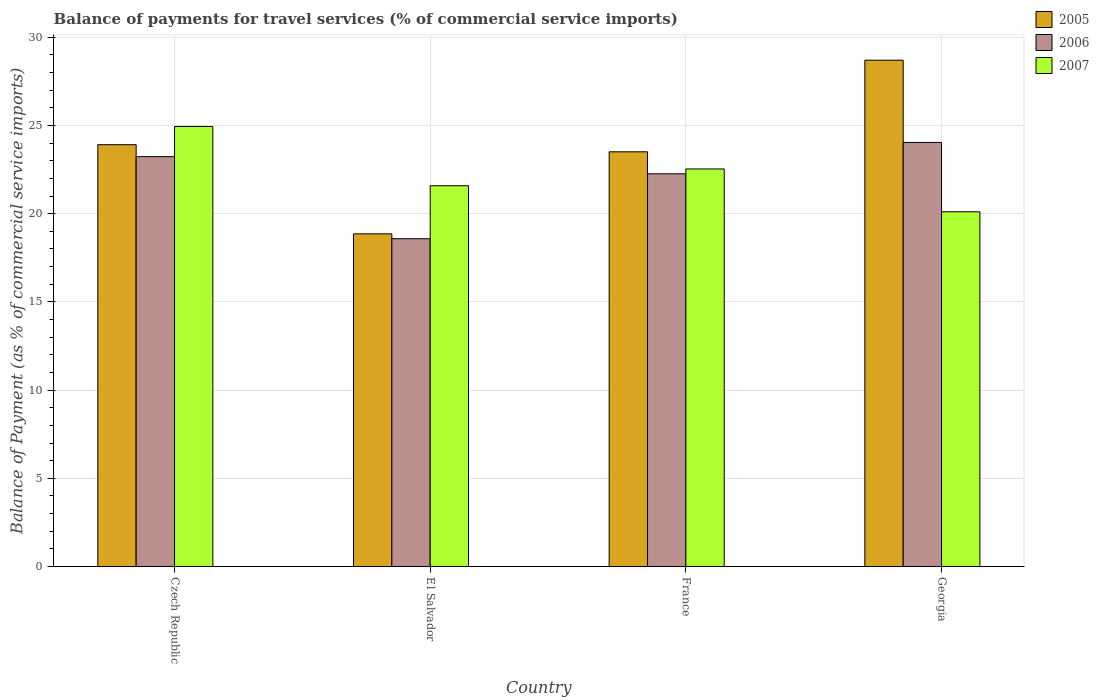Are the number of bars per tick equal to the number of legend labels?
Offer a very short reply. Yes. How many bars are there on the 2nd tick from the left?
Give a very brief answer. 3. How many bars are there on the 3rd tick from the right?
Your response must be concise. 3. What is the label of the 4th group of bars from the left?
Keep it short and to the point. Georgia. What is the balance of payments for travel services in 2006 in Georgia?
Your answer should be very brief. 24.04. Across all countries, what is the maximum balance of payments for travel services in 2007?
Offer a very short reply. 24.94. Across all countries, what is the minimum balance of payments for travel services in 2005?
Provide a succinct answer. 18.86. In which country was the balance of payments for travel services in 2007 maximum?
Keep it short and to the point. Czech Republic. In which country was the balance of payments for travel services in 2005 minimum?
Give a very brief answer. El Salvador. What is the total balance of payments for travel services in 2005 in the graph?
Offer a terse response. 94.98. What is the difference between the balance of payments for travel services in 2006 in France and that in Georgia?
Provide a succinct answer. -1.78. What is the difference between the balance of payments for travel services in 2007 in Czech Republic and the balance of payments for travel services in 2006 in France?
Offer a very short reply. 2.68. What is the average balance of payments for travel services in 2005 per country?
Keep it short and to the point. 23.75. What is the difference between the balance of payments for travel services of/in 2005 and balance of payments for travel services of/in 2007 in Georgia?
Provide a short and direct response. 8.59. In how many countries, is the balance of payments for travel services in 2007 greater than 29 %?
Give a very brief answer. 0. What is the ratio of the balance of payments for travel services in 2006 in Czech Republic to that in El Salvador?
Give a very brief answer. 1.25. Is the difference between the balance of payments for travel services in 2005 in France and Georgia greater than the difference between the balance of payments for travel services in 2007 in France and Georgia?
Your response must be concise. No. What is the difference between the highest and the second highest balance of payments for travel services in 2006?
Give a very brief answer. 1.78. What is the difference between the highest and the lowest balance of payments for travel services in 2006?
Offer a very short reply. 5.46. In how many countries, is the balance of payments for travel services in 2006 greater than the average balance of payments for travel services in 2006 taken over all countries?
Your response must be concise. 3. Is the sum of the balance of payments for travel services in 2007 in El Salvador and France greater than the maximum balance of payments for travel services in 2005 across all countries?
Your response must be concise. Yes. What does the 3rd bar from the left in Georgia represents?
Your answer should be very brief. 2007. What does the 3rd bar from the right in Czech Republic represents?
Your response must be concise. 2005. Is it the case that in every country, the sum of the balance of payments for travel services in 2006 and balance of payments for travel services in 2005 is greater than the balance of payments for travel services in 2007?
Give a very brief answer. Yes. Are all the bars in the graph horizontal?
Your answer should be very brief. No. How many countries are there in the graph?
Provide a succinct answer. 4. What is the difference between two consecutive major ticks on the Y-axis?
Make the answer very short. 5. Does the graph contain grids?
Make the answer very short. Yes. Where does the legend appear in the graph?
Your answer should be compact. Top right. How are the legend labels stacked?
Provide a short and direct response. Vertical. What is the title of the graph?
Keep it short and to the point. Balance of payments for travel services (% of commercial service imports). What is the label or title of the X-axis?
Make the answer very short. Country. What is the label or title of the Y-axis?
Make the answer very short. Balance of Payment (as % of commercial service imports). What is the Balance of Payment (as % of commercial service imports) in 2005 in Czech Republic?
Keep it short and to the point. 23.91. What is the Balance of Payment (as % of commercial service imports) in 2006 in Czech Republic?
Your answer should be very brief. 23.24. What is the Balance of Payment (as % of commercial service imports) in 2007 in Czech Republic?
Give a very brief answer. 24.94. What is the Balance of Payment (as % of commercial service imports) in 2005 in El Salvador?
Provide a short and direct response. 18.86. What is the Balance of Payment (as % of commercial service imports) of 2006 in El Salvador?
Offer a terse response. 18.58. What is the Balance of Payment (as % of commercial service imports) in 2007 in El Salvador?
Your answer should be very brief. 21.59. What is the Balance of Payment (as % of commercial service imports) in 2005 in France?
Make the answer very short. 23.51. What is the Balance of Payment (as % of commercial service imports) of 2006 in France?
Your answer should be compact. 22.26. What is the Balance of Payment (as % of commercial service imports) in 2007 in France?
Provide a succinct answer. 22.54. What is the Balance of Payment (as % of commercial service imports) of 2005 in Georgia?
Provide a short and direct response. 28.7. What is the Balance of Payment (as % of commercial service imports) in 2006 in Georgia?
Keep it short and to the point. 24.04. What is the Balance of Payment (as % of commercial service imports) in 2007 in Georgia?
Your response must be concise. 20.11. Across all countries, what is the maximum Balance of Payment (as % of commercial service imports) in 2005?
Your answer should be very brief. 28.7. Across all countries, what is the maximum Balance of Payment (as % of commercial service imports) of 2006?
Provide a short and direct response. 24.04. Across all countries, what is the maximum Balance of Payment (as % of commercial service imports) of 2007?
Offer a very short reply. 24.94. Across all countries, what is the minimum Balance of Payment (as % of commercial service imports) of 2005?
Your answer should be compact. 18.86. Across all countries, what is the minimum Balance of Payment (as % of commercial service imports) in 2006?
Offer a very short reply. 18.58. Across all countries, what is the minimum Balance of Payment (as % of commercial service imports) of 2007?
Provide a short and direct response. 20.11. What is the total Balance of Payment (as % of commercial service imports) of 2005 in the graph?
Provide a succinct answer. 94.98. What is the total Balance of Payment (as % of commercial service imports) in 2006 in the graph?
Your answer should be compact. 88.12. What is the total Balance of Payment (as % of commercial service imports) in 2007 in the graph?
Your answer should be very brief. 89.17. What is the difference between the Balance of Payment (as % of commercial service imports) in 2005 in Czech Republic and that in El Salvador?
Keep it short and to the point. 5.05. What is the difference between the Balance of Payment (as % of commercial service imports) of 2006 in Czech Republic and that in El Salvador?
Make the answer very short. 4.65. What is the difference between the Balance of Payment (as % of commercial service imports) in 2007 in Czech Republic and that in El Salvador?
Provide a short and direct response. 3.36. What is the difference between the Balance of Payment (as % of commercial service imports) of 2005 in Czech Republic and that in France?
Your response must be concise. 0.4. What is the difference between the Balance of Payment (as % of commercial service imports) in 2006 in Czech Republic and that in France?
Your answer should be compact. 0.97. What is the difference between the Balance of Payment (as % of commercial service imports) in 2007 in Czech Republic and that in France?
Your response must be concise. 2.41. What is the difference between the Balance of Payment (as % of commercial service imports) of 2005 in Czech Republic and that in Georgia?
Offer a very short reply. -4.79. What is the difference between the Balance of Payment (as % of commercial service imports) of 2006 in Czech Republic and that in Georgia?
Provide a succinct answer. -0.8. What is the difference between the Balance of Payment (as % of commercial service imports) of 2007 in Czech Republic and that in Georgia?
Your answer should be very brief. 4.84. What is the difference between the Balance of Payment (as % of commercial service imports) in 2005 in El Salvador and that in France?
Ensure brevity in your answer.  -4.65. What is the difference between the Balance of Payment (as % of commercial service imports) in 2006 in El Salvador and that in France?
Your response must be concise. -3.68. What is the difference between the Balance of Payment (as % of commercial service imports) of 2007 in El Salvador and that in France?
Your response must be concise. -0.95. What is the difference between the Balance of Payment (as % of commercial service imports) of 2005 in El Salvador and that in Georgia?
Your answer should be very brief. -9.85. What is the difference between the Balance of Payment (as % of commercial service imports) in 2006 in El Salvador and that in Georgia?
Give a very brief answer. -5.46. What is the difference between the Balance of Payment (as % of commercial service imports) in 2007 in El Salvador and that in Georgia?
Your answer should be very brief. 1.48. What is the difference between the Balance of Payment (as % of commercial service imports) of 2005 in France and that in Georgia?
Your answer should be very brief. -5.19. What is the difference between the Balance of Payment (as % of commercial service imports) of 2006 in France and that in Georgia?
Provide a short and direct response. -1.78. What is the difference between the Balance of Payment (as % of commercial service imports) of 2007 in France and that in Georgia?
Keep it short and to the point. 2.43. What is the difference between the Balance of Payment (as % of commercial service imports) of 2005 in Czech Republic and the Balance of Payment (as % of commercial service imports) of 2006 in El Salvador?
Provide a succinct answer. 5.33. What is the difference between the Balance of Payment (as % of commercial service imports) of 2005 in Czech Republic and the Balance of Payment (as % of commercial service imports) of 2007 in El Salvador?
Provide a succinct answer. 2.33. What is the difference between the Balance of Payment (as % of commercial service imports) in 2006 in Czech Republic and the Balance of Payment (as % of commercial service imports) in 2007 in El Salvador?
Keep it short and to the point. 1.65. What is the difference between the Balance of Payment (as % of commercial service imports) of 2005 in Czech Republic and the Balance of Payment (as % of commercial service imports) of 2006 in France?
Keep it short and to the point. 1.65. What is the difference between the Balance of Payment (as % of commercial service imports) in 2005 in Czech Republic and the Balance of Payment (as % of commercial service imports) in 2007 in France?
Provide a short and direct response. 1.37. What is the difference between the Balance of Payment (as % of commercial service imports) in 2006 in Czech Republic and the Balance of Payment (as % of commercial service imports) in 2007 in France?
Your answer should be compact. 0.7. What is the difference between the Balance of Payment (as % of commercial service imports) of 2005 in Czech Republic and the Balance of Payment (as % of commercial service imports) of 2006 in Georgia?
Ensure brevity in your answer.  -0.13. What is the difference between the Balance of Payment (as % of commercial service imports) in 2005 in Czech Republic and the Balance of Payment (as % of commercial service imports) in 2007 in Georgia?
Your response must be concise. 3.8. What is the difference between the Balance of Payment (as % of commercial service imports) in 2006 in Czech Republic and the Balance of Payment (as % of commercial service imports) in 2007 in Georgia?
Provide a short and direct response. 3.13. What is the difference between the Balance of Payment (as % of commercial service imports) of 2005 in El Salvador and the Balance of Payment (as % of commercial service imports) of 2006 in France?
Give a very brief answer. -3.41. What is the difference between the Balance of Payment (as % of commercial service imports) in 2005 in El Salvador and the Balance of Payment (as % of commercial service imports) in 2007 in France?
Your answer should be very brief. -3.68. What is the difference between the Balance of Payment (as % of commercial service imports) of 2006 in El Salvador and the Balance of Payment (as % of commercial service imports) of 2007 in France?
Keep it short and to the point. -3.96. What is the difference between the Balance of Payment (as % of commercial service imports) in 2005 in El Salvador and the Balance of Payment (as % of commercial service imports) in 2006 in Georgia?
Keep it short and to the point. -5.18. What is the difference between the Balance of Payment (as % of commercial service imports) in 2005 in El Salvador and the Balance of Payment (as % of commercial service imports) in 2007 in Georgia?
Provide a short and direct response. -1.25. What is the difference between the Balance of Payment (as % of commercial service imports) of 2006 in El Salvador and the Balance of Payment (as % of commercial service imports) of 2007 in Georgia?
Give a very brief answer. -1.53. What is the difference between the Balance of Payment (as % of commercial service imports) of 2005 in France and the Balance of Payment (as % of commercial service imports) of 2006 in Georgia?
Your response must be concise. -0.53. What is the difference between the Balance of Payment (as % of commercial service imports) in 2005 in France and the Balance of Payment (as % of commercial service imports) in 2007 in Georgia?
Provide a short and direct response. 3.4. What is the difference between the Balance of Payment (as % of commercial service imports) in 2006 in France and the Balance of Payment (as % of commercial service imports) in 2007 in Georgia?
Keep it short and to the point. 2.15. What is the average Balance of Payment (as % of commercial service imports) of 2005 per country?
Ensure brevity in your answer.  23.75. What is the average Balance of Payment (as % of commercial service imports) in 2006 per country?
Provide a succinct answer. 22.03. What is the average Balance of Payment (as % of commercial service imports) of 2007 per country?
Your answer should be very brief. 22.29. What is the difference between the Balance of Payment (as % of commercial service imports) in 2005 and Balance of Payment (as % of commercial service imports) in 2006 in Czech Republic?
Give a very brief answer. 0.68. What is the difference between the Balance of Payment (as % of commercial service imports) in 2005 and Balance of Payment (as % of commercial service imports) in 2007 in Czech Republic?
Keep it short and to the point. -1.03. What is the difference between the Balance of Payment (as % of commercial service imports) in 2006 and Balance of Payment (as % of commercial service imports) in 2007 in Czech Republic?
Ensure brevity in your answer.  -1.71. What is the difference between the Balance of Payment (as % of commercial service imports) in 2005 and Balance of Payment (as % of commercial service imports) in 2006 in El Salvador?
Offer a terse response. 0.28. What is the difference between the Balance of Payment (as % of commercial service imports) in 2005 and Balance of Payment (as % of commercial service imports) in 2007 in El Salvador?
Keep it short and to the point. -2.73. What is the difference between the Balance of Payment (as % of commercial service imports) of 2006 and Balance of Payment (as % of commercial service imports) of 2007 in El Salvador?
Ensure brevity in your answer.  -3. What is the difference between the Balance of Payment (as % of commercial service imports) of 2005 and Balance of Payment (as % of commercial service imports) of 2006 in France?
Your answer should be very brief. 1.25. What is the difference between the Balance of Payment (as % of commercial service imports) in 2005 and Balance of Payment (as % of commercial service imports) in 2007 in France?
Your answer should be very brief. 0.97. What is the difference between the Balance of Payment (as % of commercial service imports) of 2006 and Balance of Payment (as % of commercial service imports) of 2007 in France?
Provide a succinct answer. -0.27. What is the difference between the Balance of Payment (as % of commercial service imports) of 2005 and Balance of Payment (as % of commercial service imports) of 2006 in Georgia?
Give a very brief answer. 4.66. What is the difference between the Balance of Payment (as % of commercial service imports) in 2005 and Balance of Payment (as % of commercial service imports) in 2007 in Georgia?
Your answer should be very brief. 8.59. What is the difference between the Balance of Payment (as % of commercial service imports) in 2006 and Balance of Payment (as % of commercial service imports) in 2007 in Georgia?
Make the answer very short. 3.93. What is the ratio of the Balance of Payment (as % of commercial service imports) in 2005 in Czech Republic to that in El Salvador?
Your answer should be compact. 1.27. What is the ratio of the Balance of Payment (as % of commercial service imports) of 2006 in Czech Republic to that in El Salvador?
Provide a succinct answer. 1.25. What is the ratio of the Balance of Payment (as % of commercial service imports) of 2007 in Czech Republic to that in El Salvador?
Keep it short and to the point. 1.16. What is the ratio of the Balance of Payment (as % of commercial service imports) of 2005 in Czech Republic to that in France?
Your response must be concise. 1.02. What is the ratio of the Balance of Payment (as % of commercial service imports) in 2006 in Czech Republic to that in France?
Your answer should be very brief. 1.04. What is the ratio of the Balance of Payment (as % of commercial service imports) in 2007 in Czech Republic to that in France?
Provide a short and direct response. 1.11. What is the ratio of the Balance of Payment (as % of commercial service imports) in 2005 in Czech Republic to that in Georgia?
Provide a short and direct response. 0.83. What is the ratio of the Balance of Payment (as % of commercial service imports) in 2006 in Czech Republic to that in Georgia?
Give a very brief answer. 0.97. What is the ratio of the Balance of Payment (as % of commercial service imports) in 2007 in Czech Republic to that in Georgia?
Your answer should be compact. 1.24. What is the ratio of the Balance of Payment (as % of commercial service imports) in 2005 in El Salvador to that in France?
Make the answer very short. 0.8. What is the ratio of the Balance of Payment (as % of commercial service imports) of 2006 in El Salvador to that in France?
Give a very brief answer. 0.83. What is the ratio of the Balance of Payment (as % of commercial service imports) of 2007 in El Salvador to that in France?
Give a very brief answer. 0.96. What is the ratio of the Balance of Payment (as % of commercial service imports) of 2005 in El Salvador to that in Georgia?
Provide a succinct answer. 0.66. What is the ratio of the Balance of Payment (as % of commercial service imports) of 2006 in El Salvador to that in Georgia?
Your answer should be compact. 0.77. What is the ratio of the Balance of Payment (as % of commercial service imports) of 2007 in El Salvador to that in Georgia?
Offer a terse response. 1.07. What is the ratio of the Balance of Payment (as % of commercial service imports) of 2005 in France to that in Georgia?
Give a very brief answer. 0.82. What is the ratio of the Balance of Payment (as % of commercial service imports) of 2006 in France to that in Georgia?
Your response must be concise. 0.93. What is the ratio of the Balance of Payment (as % of commercial service imports) in 2007 in France to that in Georgia?
Keep it short and to the point. 1.12. What is the difference between the highest and the second highest Balance of Payment (as % of commercial service imports) of 2005?
Your answer should be compact. 4.79. What is the difference between the highest and the second highest Balance of Payment (as % of commercial service imports) of 2006?
Offer a very short reply. 0.8. What is the difference between the highest and the second highest Balance of Payment (as % of commercial service imports) of 2007?
Your answer should be very brief. 2.41. What is the difference between the highest and the lowest Balance of Payment (as % of commercial service imports) of 2005?
Make the answer very short. 9.85. What is the difference between the highest and the lowest Balance of Payment (as % of commercial service imports) of 2006?
Offer a terse response. 5.46. What is the difference between the highest and the lowest Balance of Payment (as % of commercial service imports) in 2007?
Offer a terse response. 4.84. 